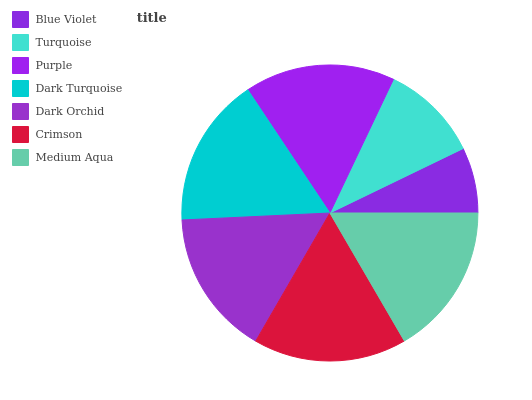Is Blue Violet the minimum?
Answer yes or no. Yes. Is Crimson the maximum?
Answer yes or no. Yes. Is Turquoise the minimum?
Answer yes or no. No. Is Turquoise the maximum?
Answer yes or no. No. Is Turquoise greater than Blue Violet?
Answer yes or no. Yes. Is Blue Violet less than Turquoise?
Answer yes or no. Yes. Is Blue Violet greater than Turquoise?
Answer yes or no. No. Is Turquoise less than Blue Violet?
Answer yes or no. No. Is Dark Turquoise the high median?
Answer yes or no. Yes. Is Dark Turquoise the low median?
Answer yes or no. Yes. Is Dark Orchid the high median?
Answer yes or no. No. Is Turquoise the low median?
Answer yes or no. No. 